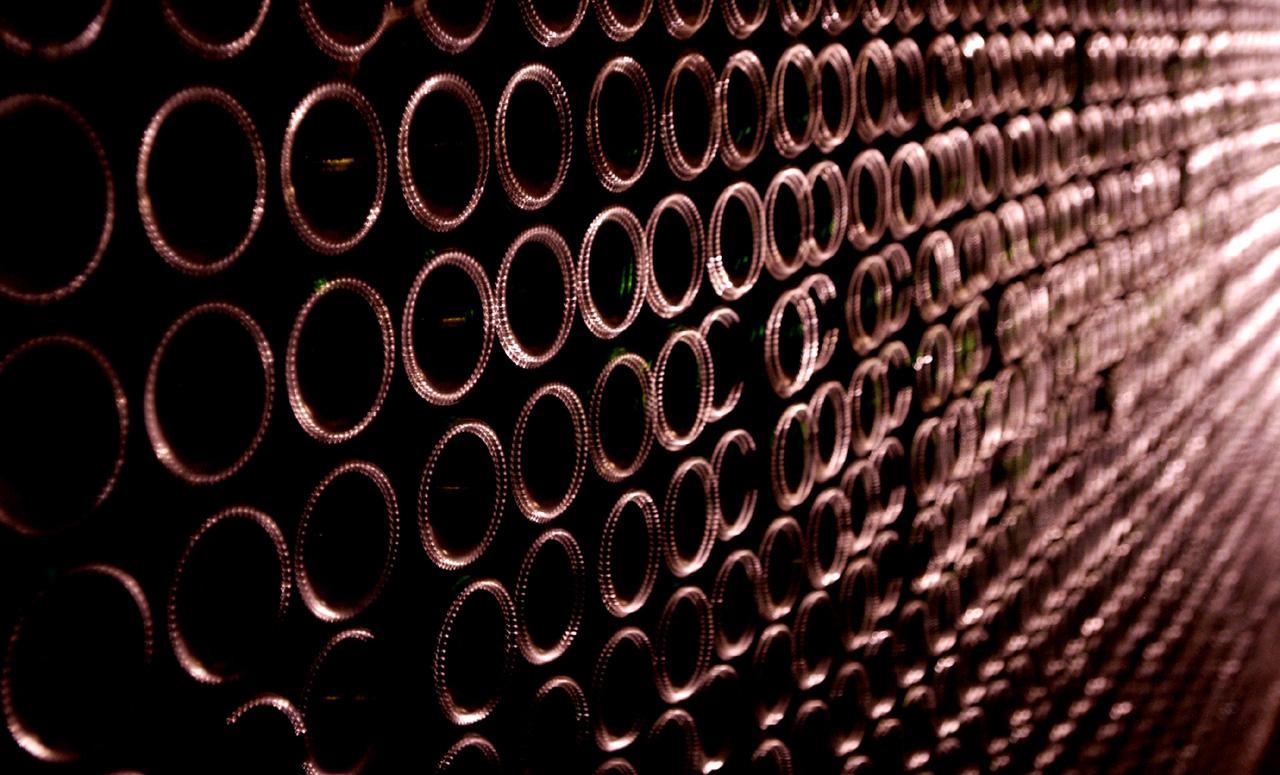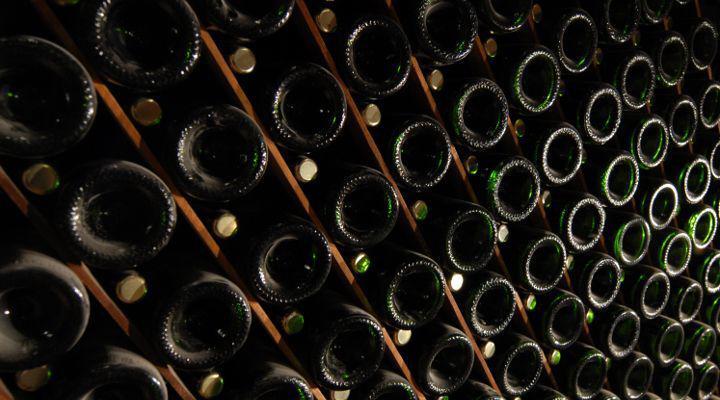The first image is the image on the left, the second image is the image on the right. Examine the images to the left and right. Is the description "There is a glass of red wine next to a bottle of wine in one of the images" accurate? Answer yes or no. No. The first image is the image on the left, the second image is the image on the right. Considering the images on both sides, is "A single bottle and glass of wine are in one of the images." valid? Answer yes or no. No. 